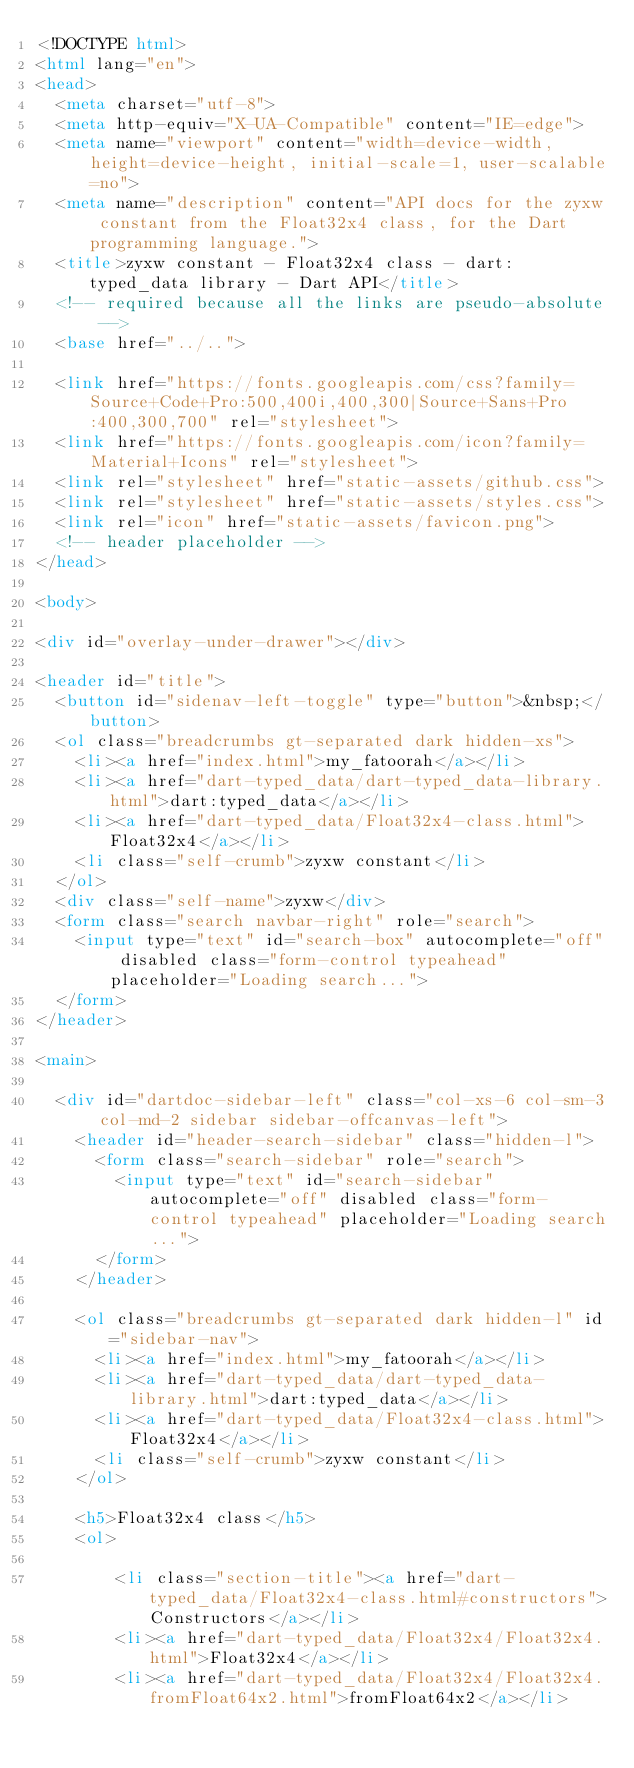<code> <loc_0><loc_0><loc_500><loc_500><_HTML_><!DOCTYPE html>
<html lang="en">
<head>
  <meta charset="utf-8">
  <meta http-equiv="X-UA-Compatible" content="IE=edge">
  <meta name="viewport" content="width=device-width, height=device-height, initial-scale=1, user-scalable=no">
  <meta name="description" content="API docs for the zyxw constant from the Float32x4 class, for the Dart programming language.">
  <title>zyxw constant - Float32x4 class - dart:typed_data library - Dart API</title>
  <!-- required because all the links are pseudo-absolute -->
  <base href="../..">

  <link href="https://fonts.googleapis.com/css?family=Source+Code+Pro:500,400i,400,300|Source+Sans+Pro:400,300,700" rel="stylesheet">
  <link href="https://fonts.googleapis.com/icon?family=Material+Icons" rel="stylesheet">
  <link rel="stylesheet" href="static-assets/github.css">
  <link rel="stylesheet" href="static-assets/styles.css">
  <link rel="icon" href="static-assets/favicon.png">
  <!-- header placeholder -->
</head>

<body>

<div id="overlay-under-drawer"></div>

<header id="title">
  <button id="sidenav-left-toggle" type="button">&nbsp;</button>
  <ol class="breadcrumbs gt-separated dark hidden-xs">
    <li><a href="index.html">my_fatoorah</a></li>
    <li><a href="dart-typed_data/dart-typed_data-library.html">dart:typed_data</a></li>
    <li><a href="dart-typed_data/Float32x4-class.html">Float32x4</a></li>
    <li class="self-crumb">zyxw constant</li>
  </ol>
  <div class="self-name">zyxw</div>
  <form class="search navbar-right" role="search">
    <input type="text" id="search-box" autocomplete="off" disabled class="form-control typeahead" placeholder="Loading search...">
  </form>
</header>

<main>

  <div id="dartdoc-sidebar-left" class="col-xs-6 col-sm-3 col-md-2 sidebar sidebar-offcanvas-left">
    <header id="header-search-sidebar" class="hidden-l">
      <form class="search-sidebar" role="search">
        <input type="text" id="search-sidebar" autocomplete="off" disabled class="form-control typeahead" placeholder="Loading search...">
      </form>
    </header>
    
    <ol class="breadcrumbs gt-separated dark hidden-l" id="sidebar-nav">
      <li><a href="index.html">my_fatoorah</a></li>
      <li><a href="dart-typed_data/dart-typed_data-library.html">dart:typed_data</a></li>
      <li><a href="dart-typed_data/Float32x4-class.html">Float32x4</a></li>
      <li class="self-crumb">zyxw constant</li>
    </ol>
    
    <h5>Float32x4 class</h5>
    <ol>
    
        <li class="section-title"><a href="dart-typed_data/Float32x4-class.html#constructors">Constructors</a></li>
        <li><a href="dart-typed_data/Float32x4/Float32x4.html">Float32x4</a></li>
        <li><a href="dart-typed_data/Float32x4/Float32x4.fromFloat64x2.html">fromFloat64x2</a></li></code> 